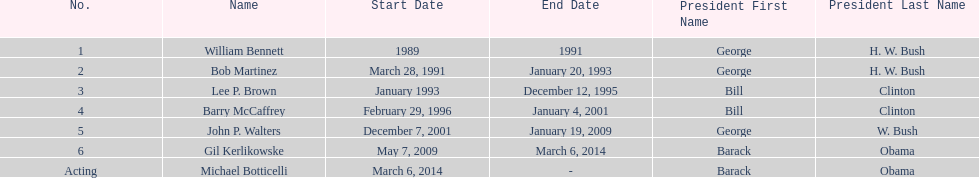How many directors served more than 3 years? 3. 